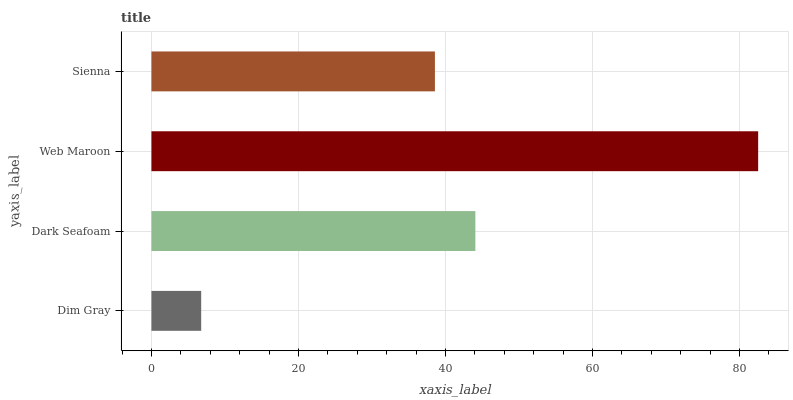Is Dim Gray the minimum?
Answer yes or no. Yes. Is Web Maroon the maximum?
Answer yes or no. Yes. Is Dark Seafoam the minimum?
Answer yes or no. No. Is Dark Seafoam the maximum?
Answer yes or no. No. Is Dark Seafoam greater than Dim Gray?
Answer yes or no. Yes. Is Dim Gray less than Dark Seafoam?
Answer yes or no. Yes. Is Dim Gray greater than Dark Seafoam?
Answer yes or no. No. Is Dark Seafoam less than Dim Gray?
Answer yes or no. No. Is Dark Seafoam the high median?
Answer yes or no. Yes. Is Sienna the low median?
Answer yes or no. Yes. Is Sienna the high median?
Answer yes or no. No. Is Dim Gray the low median?
Answer yes or no. No. 